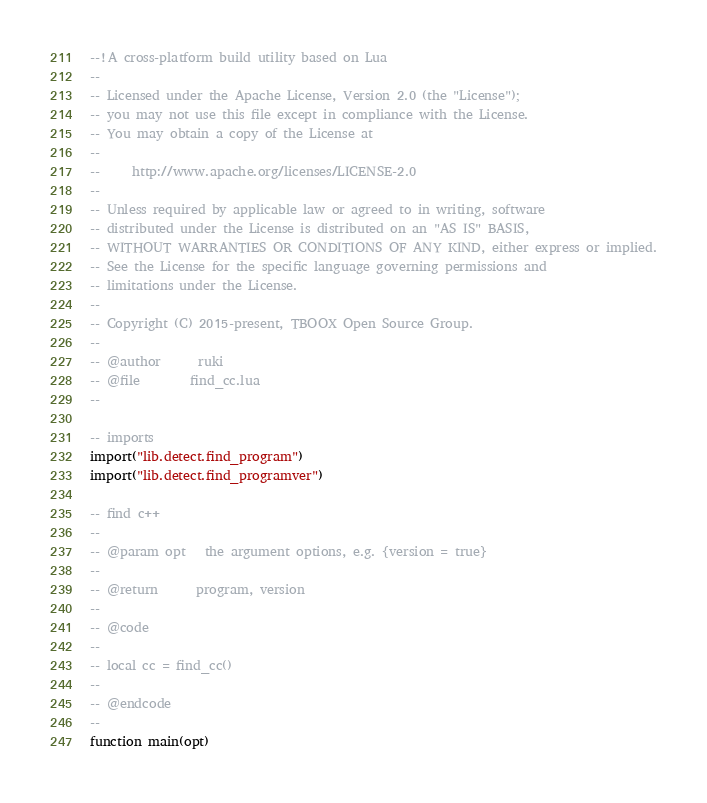<code> <loc_0><loc_0><loc_500><loc_500><_Lua_>--!A cross-platform build utility based on Lua
--
-- Licensed under the Apache License, Version 2.0 (the "License");
-- you may not use this file except in compliance with the License.
-- You may obtain a copy of the License at
--
--     http://www.apache.org/licenses/LICENSE-2.0
--
-- Unless required by applicable law or agreed to in writing, software
-- distributed under the License is distributed on an "AS IS" BASIS,
-- WITHOUT WARRANTIES OR CONDITIONS OF ANY KIND, either express or implied.
-- See the License for the specific language governing permissions and
-- limitations under the License.
--
-- Copyright (C) 2015-present, TBOOX Open Source Group.
--
-- @author      ruki
-- @file        find_cc.lua
--

-- imports
import("lib.detect.find_program")
import("lib.detect.find_programver")

-- find c++
--
-- @param opt   the argument options, e.g. {version = true}
--
-- @return      program, version
--
-- @code
--
-- local cc = find_cc()
--
-- @endcode
--
function main(opt)
</code> 